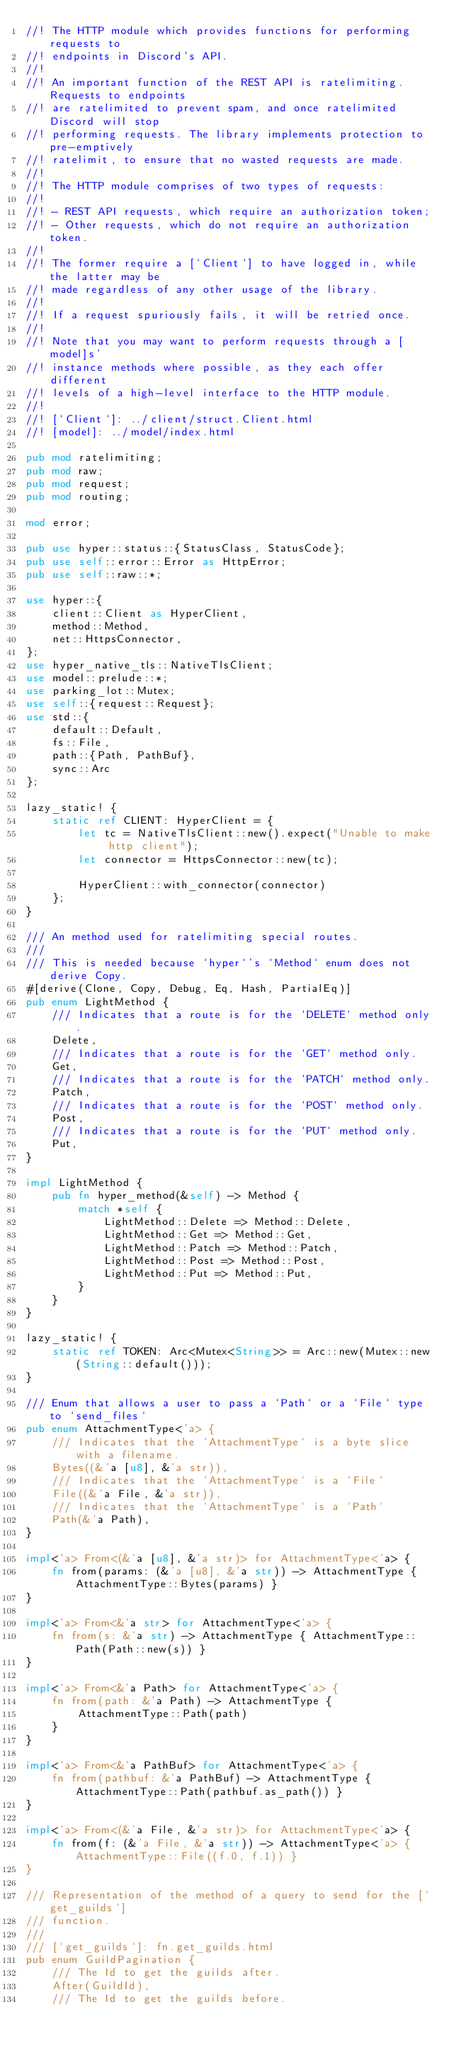Convert code to text. <code><loc_0><loc_0><loc_500><loc_500><_Rust_>//! The HTTP module which provides functions for performing requests to
//! endpoints in Discord's API.
//!
//! An important function of the REST API is ratelimiting. Requests to endpoints
//! are ratelimited to prevent spam, and once ratelimited Discord will stop
//! performing requests. The library implements protection to pre-emptively
//! ratelimit, to ensure that no wasted requests are made.
//!
//! The HTTP module comprises of two types of requests:
//!
//! - REST API requests, which require an authorization token;
//! - Other requests, which do not require an authorization token.
//!
//! The former require a [`Client`] to have logged in, while the latter may be
//! made regardless of any other usage of the library.
//!
//! If a request spuriously fails, it will be retried once.
//!
//! Note that you may want to perform requests through a [model]s'
//! instance methods where possible, as they each offer different
//! levels of a high-level interface to the HTTP module.
//!
//! [`Client`]: ../client/struct.Client.html
//! [model]: ../model/index.html

pub mod ratelimiting;
pub mod raw;
pub mod request;
pub mod routing;

mod error;

pub use hyper::status::{StatusClass, StatusCode};
pub use self::error::Error as HttpError;
pub use self::raw::*;

use hyper::{
    client::Client as HyperClient,
    method::Method,
    net::HttpsConnector,
};
use hyper_native_tls::NativeTlsClient;
use model::prelude::*;
use parking_lot::Mutex;
use self::{request::Request};
use std::{
    default::Default,
    fs::File,
    path::{Path, PathBuf},
    sync::Arc
};

lazy_static! {
    static ref CLIENT: HyperClient = {
        let tc = NativeTlsClient::new().expect("Unable to make http client");
        let connector = HttpsConnector::new(tc);

        HyperClient::with_connector(connector)
    };
}

/// An method used for ratelimiting special routes.
///
/// This is needed because `hyper`'s `Method` enum does not derive Copy.
#[derive(Clone, Copy, Debug, Eq, Hash, PartialEq)]
pub enum LightMethod {
    /// Indicates that a route is for the `DELETE` method only.
    Delete,
    /// Indicates that a route is for the `GET` method only.
    Get,
    /// Indicates that a route is for the `PATCH` method only.
    Patch,
    /// Indicates that a route is for the `POST` method only.
    Post,
    /// Indicates that a route is for the `PUT` method only.
    Put,
}

impl LightMethod {
    pub fn hyper_method(&self) -> Method {
        match *self {
            LightMethod::Delete => Method::Delete,
            LightMethod::Get => Method::Get,
            LightMethod::Patch => Method::Patch,
            LightMethod::Post => Method::Post,
            LightMethod::Put => Method::Put,
        }
    }
}

lazy_static! {
    static ref TOKEN: Arc<Mutex<String>> = Arc::new(Mutex::new(String::default()));
}

/// Enum that allows a user to pass a `Path` or a `File` type to `send_files`
pub enum AttachmentType<'a> {
    /// Indicates that the `AttachmentType` is a byte slice with a filename.
    Bytes((&'a [u8], &'a str)),
    /// Indicates that the `AttachmentType` is a `File`
    File((&'a File, &'a str)),
    /// Indicates that the `AttachmentType` is a `Path`
    Path(&'a Path),
}

impl<'a> From<(&'a [u8], &'a str)> for AttachmentType<'a> {
    fn from(params: (&'a [u8], &'a str)) -> AttachmentType { AttachmentType::Bytes(params) }
}

impl<'a> From<&'a str> for AttachmentType<'a> {
    fn from(s: &'a str) -> AttachmentType { AttachmentType::Path(Path::new(s)) }
}

impl<'a> From<&'a Path> for AttachmentType<'a> {
    fn from(path: &'a Path) -> AttachmentType {
        AttachmentType::Path(path)
    }
}

impl<'a> From<&'a PathBuf> for AttachmentType<'a> {
    fn from(pathbuf: &'a PathBuf) -> AttachmentType { AttachmentType::Path(pathbuf.as_path()) }
}

impl<'a> From<(&'a File, &'a str)> for AttachmentType<'a> {
    fn from(f: (&'a File, &'a str)) -> AttachmentType<'a> { AttachmentType::File((f.0, f.1)) }
}

/// Representation of the method of a query to send for the [`get_guilds`]
/// function.
///
/// [`get_guilds`]: fn.get_guilds.html
pub enum GuildPagination {
    /// The Id to get the guilds after.
    After(GuildId),
    /// The Id to get the guilds before.</code> 